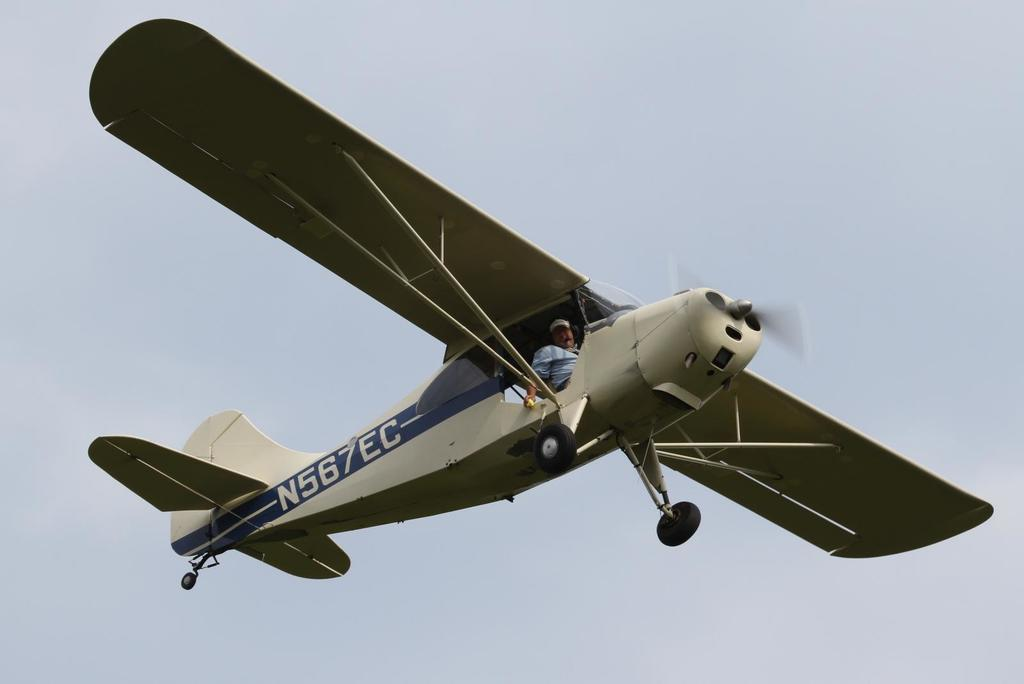What is the main subject of the image? The main subject of the image is an aircraft flying in the air. Can you describe the location of the aircraft in the image? The aircraft is in the air in the image. Is there anyone inside the aircraft? Yes, there is a person inside the aircraft. What can be seen in the background of the image? The sky is visible in the background of the image. Can you see any bubbles floating around the aircraft in the image? No, there are no bubbles visible in the image. Is there a deer running alongside the aircraft in the image? No, there is no deer present in the image. 